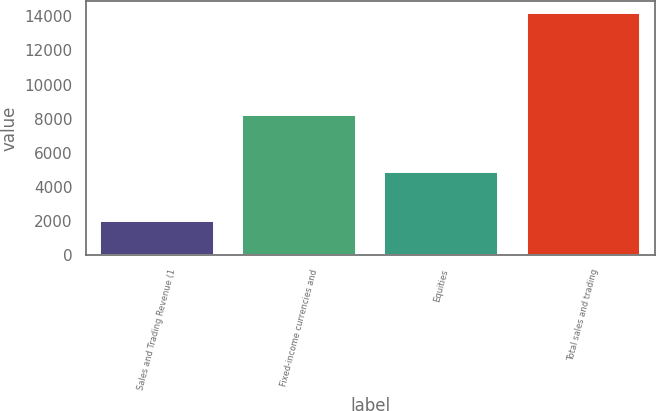Convert chart. <chart><loc_0><loc_0><loc_500><loc_500><bar_chart><fcel>Sales and Trading Revenue (1<fcel>Fixed-income currencies and<fcel>Equities<fcel>Total sales and trading<nl><fcel>2018<fcel>8186<fcel>4876<fcel>14182.6<nl></chart> 